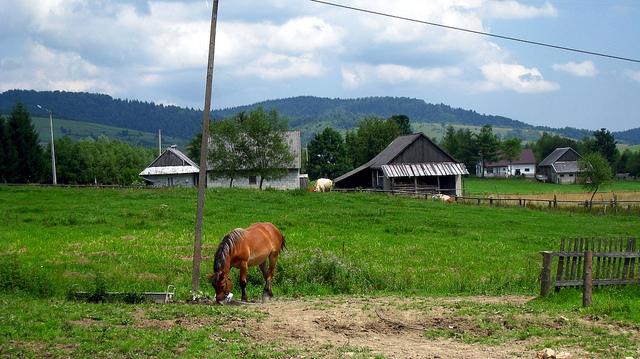Is this an urban area?
Answer briefly. No. How many horses are there?
Short answer required. 1. Is this a city or country?
Write a very short answer. Country. How many horses are on the picture?
Quick response, please. 1. 